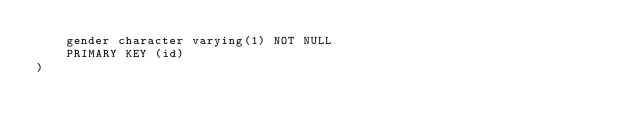<code> <loc_0><loc_0><loc_500><loc_500><_SQL_>	gender character varying(1) NOT NULL
	PRIMARY KEY (id)
)
</code> 